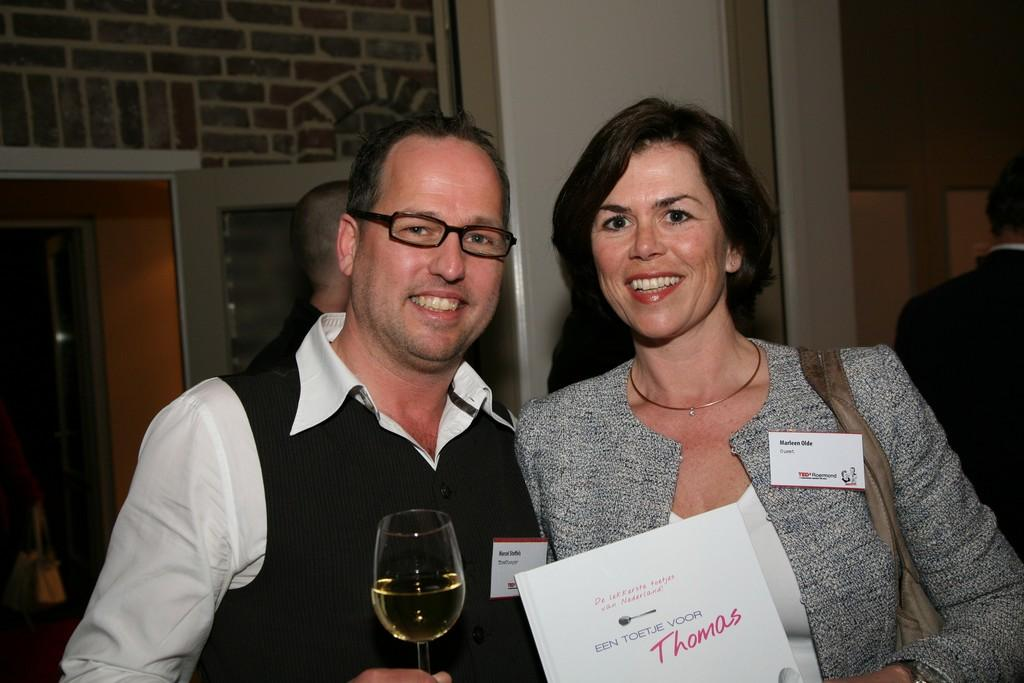Provide a one-sentence caption for the provided image. The persons name on the right is Marleen Olde. 